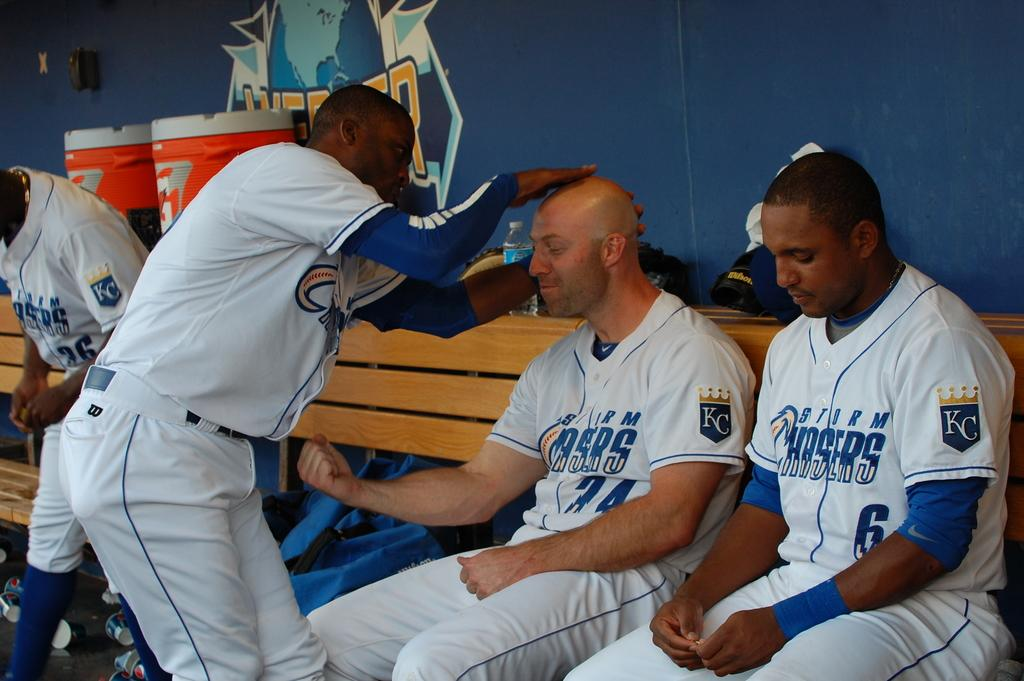<image>
Offer a succinct explanation of the picture presented. A man rubs the bald head of his team mate, who is wearing a jersey wih the team name Chasers on it. 